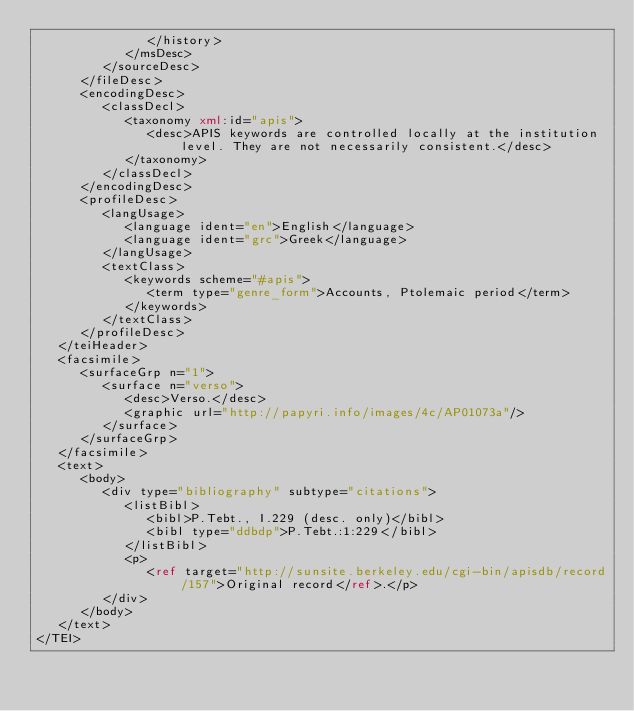<code> <loc_0><loc_0><loc_500><loc_500><_XML_>               </history>
            </msDesc>
         </sourceDesc>
      </fileDesc>
      <encodingDesc>
         <classDecl>
            <taxonomy xml:id="apis">
               <desc>APIS keywords are controlled locally at the institution level. They are not necessarily consistent.</desc>
            </taxonomy>
         </classDecl>
      </encodingDesc>
      <profileDesc>
         <langUsage>
            <language ident="en">English</language>
            <language ident="grc">Greek</language>
         </langUsage>
         <textClass>
            <keywords scheme="#apis">
               <term type="genre_form">Accounts, Ptolemaic period</term>
            </keywords>
         </textClass>
      </profileDesc>
   </teiHeader>
   <facsimile>
      <surfaceGrp n="1">
         <surface n="verso">
            <desc>Verso.</desc>
            <graphic url="http://papyri.info/images/4c/AP01073a"/>
         </surface>
      </surfaceGrp>
   </facsimile>
   <text>
      <body>
         <div type="bibliography" subtype="citations">
            <listBibl>
               <bibl>P.Tebt., I.229 (desc. only)</bibl>
               <bibl type="ddbdp">P.Tebt.:1:229</bibl>
            </listBibl>
            <p>
               <ref target="http://sunsite.berkeley.edu/cgi-bin/apisdb/record/157">Original record</ref>.</p>
         </div>
      </body>
   </text>
</TEI></code> 